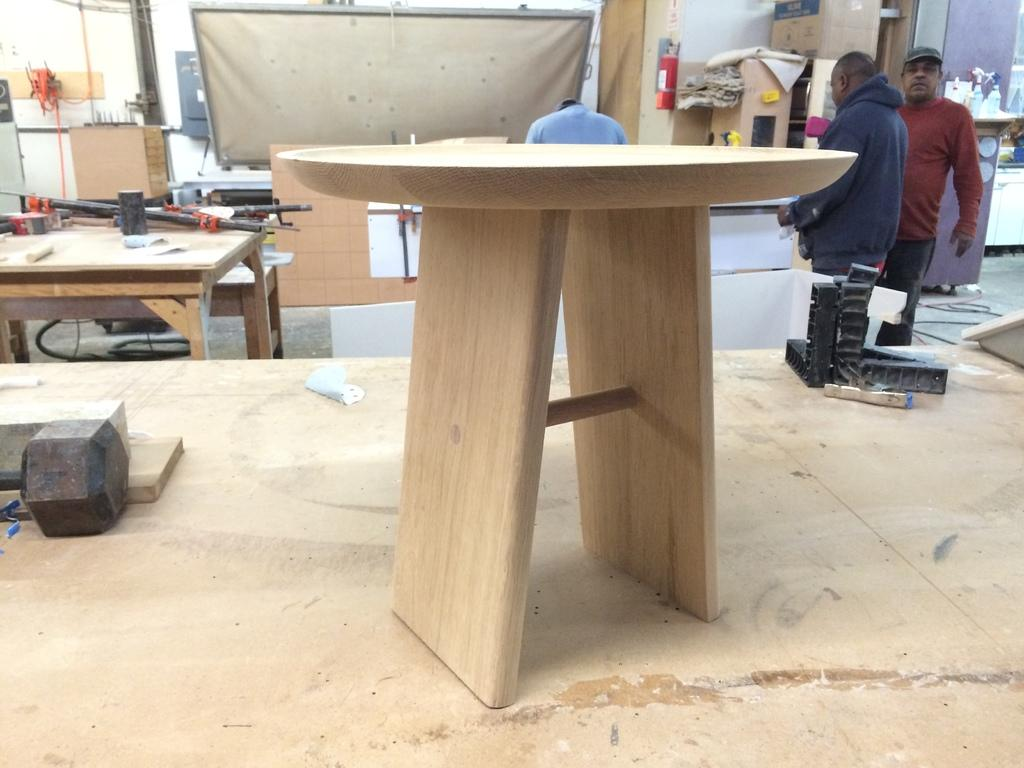What is the main object in the foreground of the image? There is a table in the image. Can you describe the people in the background? Two men are standing in the background. What architectural feature can be seen in the image? There is a pillar in the image. What is the board used for in the image? The purpose of the board in the image is not specified, but it is present. What type of objects are on the table? There are machines on the table. What type of plants can be seen in the garden in the image? There is no garden present in the image, so it is not possible to answer that question. 